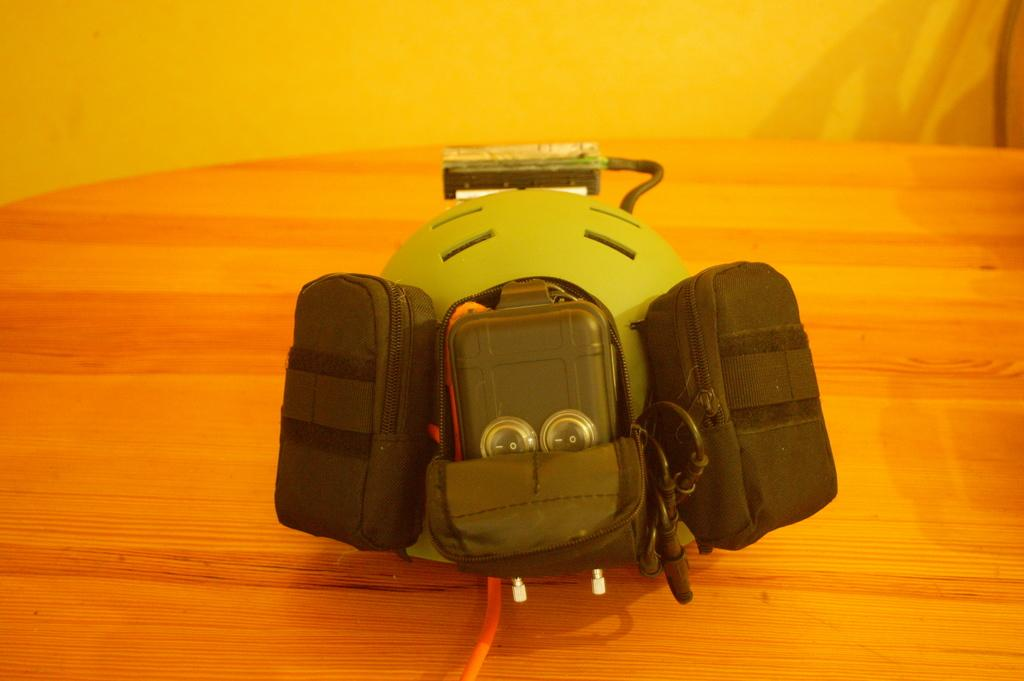What object can be seen in the image? There is a toy in the image. Where is the toy located? The toy is on a table. Is there a can in the image? There is no mention of a can in the provided facts, so we cannot determine if there is one in the image. 